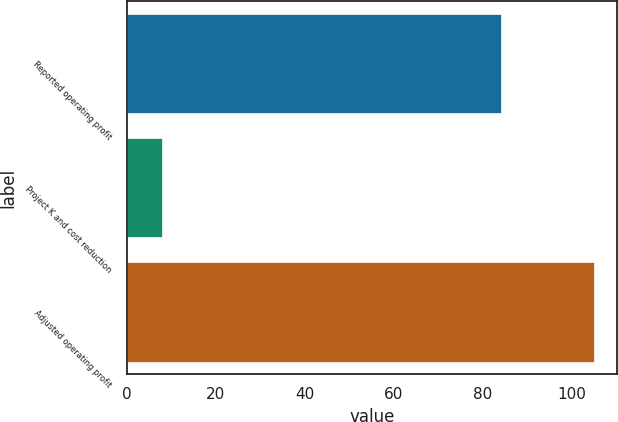<chart> <loc_0><loc_0><loc_500><loc_500><bar_chart><fcel>Reported operating profit<fcel>Project K and cost reduction<fcel>Adjusted operating profit<nl><fcel>84<fcel>8<fcel>105<nl></chart> 